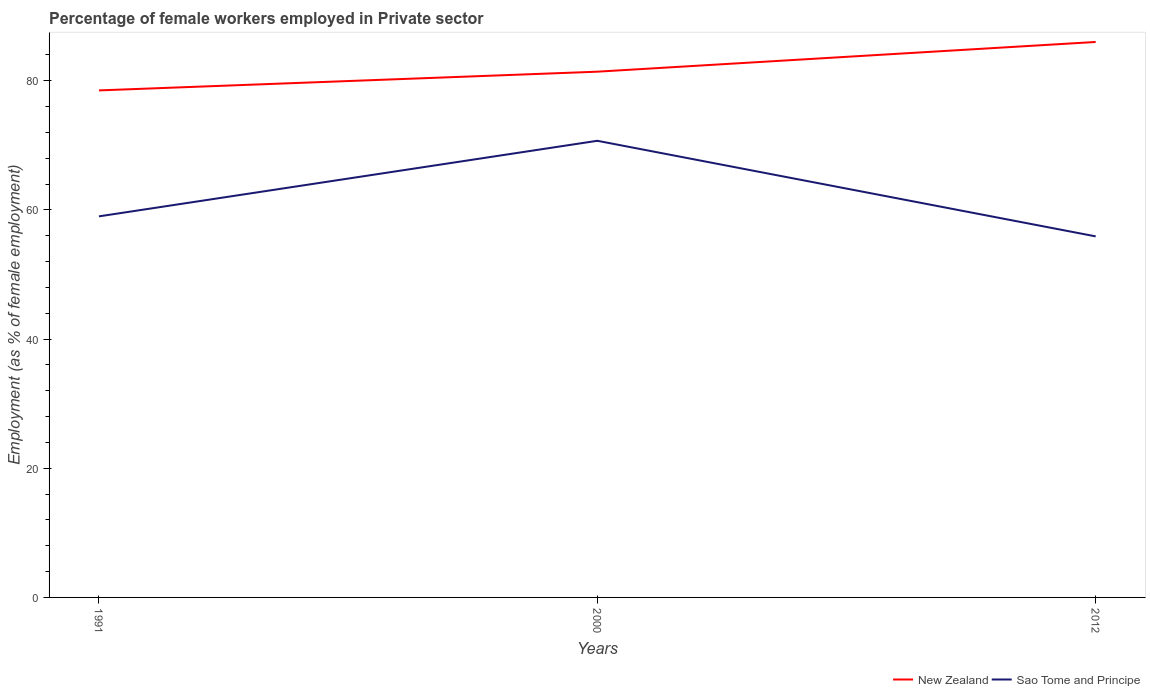How many different coloured lines are there?
Keep it short and to the point. 2. Across all years, what is the maximum percentage of females employed in Private sector in Sao Tome and Principe?
Ensure brevity in your answer.  55.9. What is the total percentage of females employed in Private sector in Sao Tome and Principe in the graph?
Keep it short and to the point. 14.8. What is the difference between the highest and the second highest percentage of females employed in Private sector in Sao Tome and Principe?
Your answer should be very brief. 14.8. What is the difference between the highest and the lowest percentage of females employed in Private sector in New Zealand?
Keep it short and to the point. 1. How many lines are there?
Offer a very short reply. 2. Does the graph contain any zero values?
Ensure brevity in your answer.  No. Does the graph contain grids?
Keep it short and to the point. No. Where does the legend appear in the graph?
Keep it short and to the point. Bottom right. How are the legend labels stacked?
Provide a succinct answer. Horizontal. What is the title of the graph?
Ensure brevity in your answer.  Percentage of female workers employed in Private sector. Does "Serbia" appear as one of the legend labels in the graph?
Offer a terse response. No. What is the label or title of the Y-axis?
Give a very brief answer. Employment (as % of female employment). What is the Employment (as % of female employment) in New Zealand in 1991?
Give a very brief answer. 78.5. What is the Employment (as % of female employment) of Sao Tome and Principe in 1991?
Your answer should be very brief. 59. What is the Employment (as % of female employment) in New Zealand in 2000?
Your answer should be very brief. 81.4. What is the Employment (as % of female employment) of Sao Tome and Principe in 2000?
Provide a short and direct response. 70.7. What is the Employment (as % of female employment) in New Zealand in 2012?
Offer a very short reply. 86. What is the Employment (as % of female employment) of Sao Tome and Principe in 2012?
Offer a very short reply. 55.9. Across all years, what is the maximum Employment (as % of female employment) in Sao Tome and Principe?
Ensure brevity in your answer.  70.7. Across all years, what is the minimum Employment (as % of female employment) in New Zealand?
Provide a short and direct response. 78.5. Across all years, what is the minimum Employment (as % of female employment) of Sao Tome and Principe?
Make the answer very short. 55.9. What is the total Employment (as % of female employment) of New Zealand in the graph?
Your answer should be compact. 245.9. What is the total Employment (as % of female employment) of Sao Tome and Principe in the graph?
Your answer should be very brief. 185.6. What is the difference between the Employment (as % of female employment) in New Zealand in 1991 and that in 2000?
Provide a short and direct response. -2.9. What is the difference between the Employment (as % of female employment) in Sao Tome and Principe in 1991 and that in 2000?
Keep it short and to the point. -11.7. What is the difference between the Employment (as % of female employment) of New Zealand in 1991 and that in 2012?
Your answer should be very brief. -7.5. What is the difference between the Employment (as % of female employment) of Sao Tome and Principe in 1991 and that in 2012?
Ensure brevity in your answer.  3.1. What is the difference between the Employment (as % of female employment) in New Zealand in 2000 and that in 2012?
Your response must be concise. -4.6. What is the difference between the Employment (as % of female employment) of New Zealand in 1991 and the Employment (as % of female employment) of Sao Tome and Principe in 2000?
Offer a terse response. 7.8. What is the difference between the Employment (as % of female employment) of New Zealand in 1991 and the Employment (as % of female employment) of Sao Tome and Principe in 2012?
Offer a very short reply. 22.6. What is the difference between the Employment (as % of female employment) in New Zealand in 2000 and the Employment (as % of female employment) in Sao Tome and Principe in 2012?
Provide a succinct answer. 25.5. What is the average Employment (as % of female employment) of New Zealand per year?
Your response must be concise. 81.97. What is the average Employment (as % of female employment) in Sao Tome and Principe per year?
Your response must be concise. 61.87. In the year 1991, what is the difference between the Employment (as % of female employment) in New Zealand and Employment (as % of female employment) in Sao Tome and Principe?
Make the answer very short. 19.5. In the year 2012, what is the difference between the Employment (as % of female employment) in New Zealand and Employment (as % of female employment) in Sao Tome and Principe?
Offer a very short reply. 30.1. What is the ratio of the Employment (as % of female employment) of New Zealand in 1991 to that in 2000?
Your answer should be very brief. 0.96. What is the ratio of the Employment (as % of female employment) in Sao Tome and Principe in 1991 to that in 2000?
Ensure brevity in your answer.  0.83. What is the ratio of the Employment (as % of female employment) of New Zealand in 1991 to that in 2012?
Your answer should be very brief. 0.91. What is the ratio of the Employment (as % of female employment) in Sao Tome and Principe in 1991 to that in 2012?
Provide a succinct answer. 1.06. What is the ratio of the Employment (as % of female employment) in New Zealand in 2000 to that in 2012?
Your response must be concise. 0.95. What is the ratio of the Employment (as % of female employment) of Sao Tome and Principe in 2000 to that in 2012?
Your answer should be very brief. 1.26. What is the difference between the highest and the lowest Employment (as % of female employment) of New Zealand?
Your response must be concise. 7.5. 